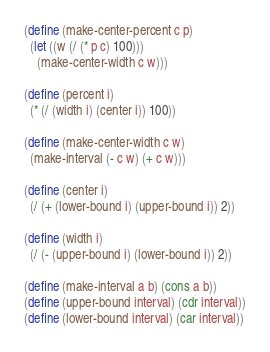Convert code to text. <code><loc_0><loc_0><loc_500><loc_500><_Scheme_>(define (make-center-percent c p)
  (let ((w (/ (* p c) 100)))
    (make-center-width c w)))

(define (percent i)
  (* (/ (width i) (center i)) 100))

(define (make-center-width c w)
  (make-interval (- c w) (+ c w)))

(define (center i)
  (/ (+ (lower-bound i) (upper-bound i)) 2))

(define (width i)
  (/ (- (upper-bound i) (lower-bound i)) 2))

(define (make-interval a b) (cons a b))
(define (upper-bound interval) (cdr interval))
(define (lower-bound interval) (car interval))
</code> 